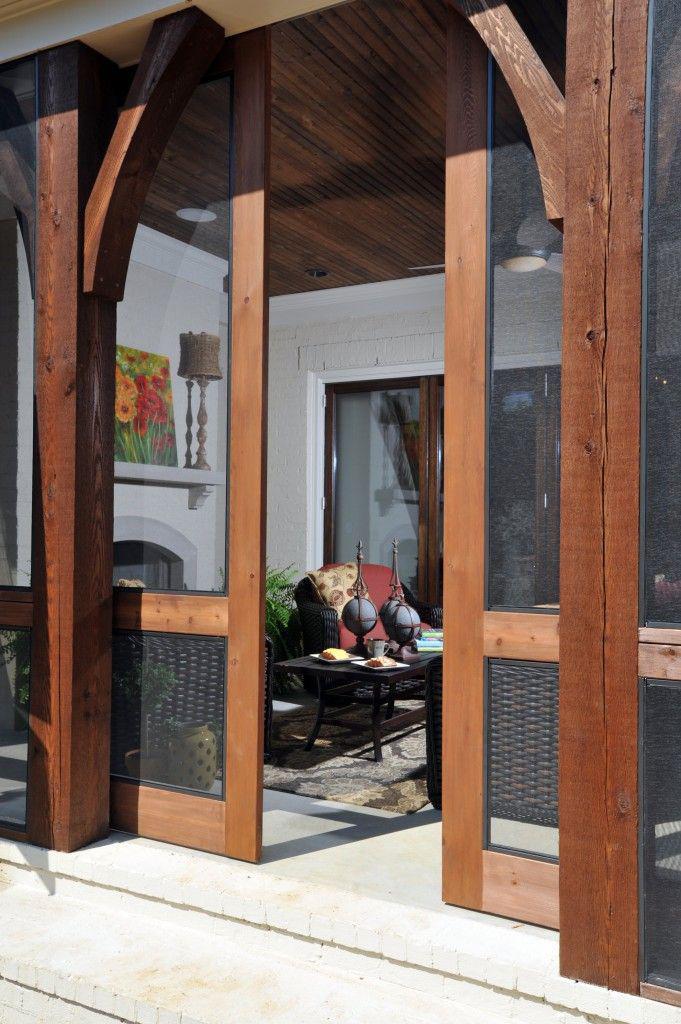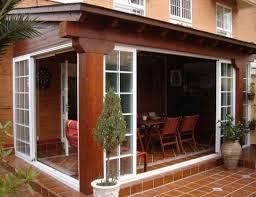The first image is the image on the left, the second image is the image on the right. For the images displayed, is the sentence "The image on the left has a white wood-trimmed glass door." factually correct? Answer yes or no. No. The first image is the image on the left, the second image is the image on the right. Assess this claim about the two images: "All the doors are closed.". Correct or not? Answer yes or no. No. 